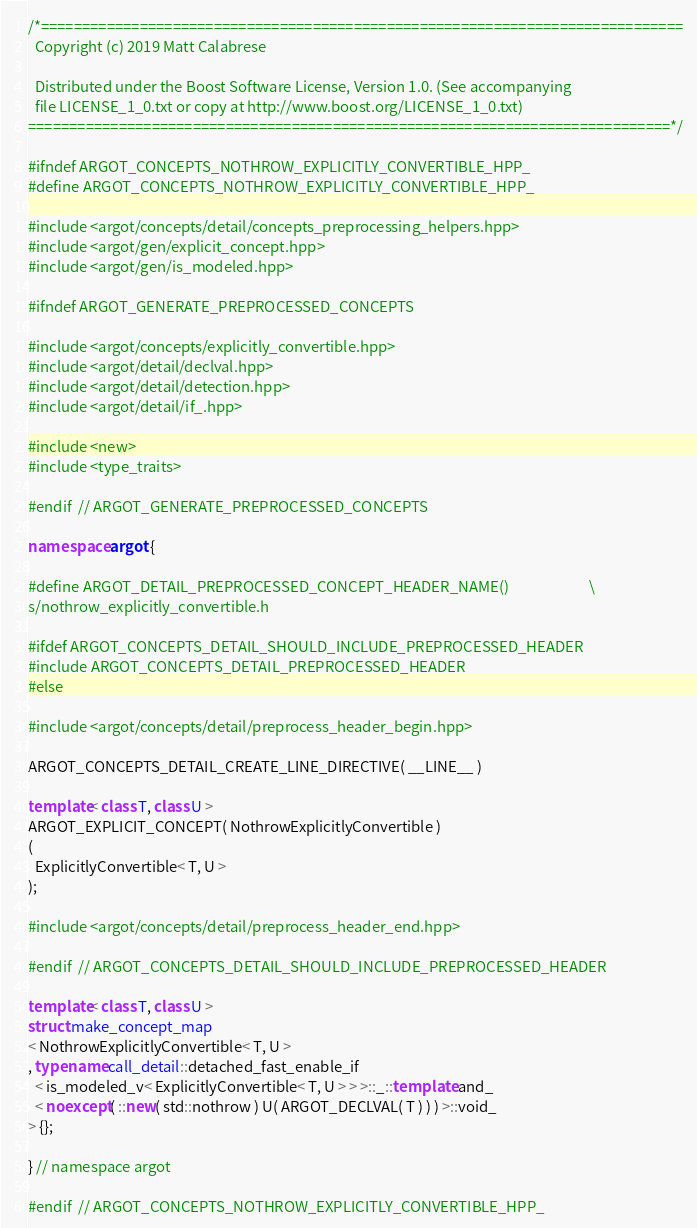<code> <loc_0><loc_0><loc_500><loc_500><_C++_>/*==============================================================================
  Copyright (c) 2019 Matt Calabrese

  Distributed under the Boost Software License, Version 1.0. (See accompanying
  file LICENSE_1_0.txt or copy at http://www.boost.org/LICENSE_1_0.txt)
==============================================================================*/

#ifndef ARGOT_CONCEPTS_NOTHROW_EXPLICITLY_CONVERTIBLE_HPP_
#define ARGOT_CONCEPTS_NOTHROW_EXPLICITLY_CONVERTIBLE_HPP_

#include <argot/concepts/detail/concepts_preprocessing_helpers.hpp>
#include <argot/gen/explicit_concept.hpp>
#include <argot/gen/is_modeled.hpp>

#ifndef ARGOT_GENERATE_PREPROCESSED_CONCEPTS

#include <argot/concepts/explicitly_convertible.hpp>
#include <argot/detail/declval.hpp>
#include <argot/detail/detection.hpp>
#include <argot/detail/if_.hpp>

#include <new>
#include <type_traits>

#endif  // ARGOT_GENERATE_PREPROCESSED_CONCEPTS

namespace argot {

#define ARGOT_DETAIL_PREPROCESSED_CONCEPT_HEADER_NAME()                        \
s/nothrow_explicitly_convertible.h

#ifdef ARGOT_CONCEPTS_DETAIL_SHOULD_INCLUDE_PREPROCESSED_HEADER
#include ARGOT_CONCEPTS_DETAIL_PREPROCESSED_HEADER
#else

#include <argot/concepts/detail/preprocess_header_begin.hpp>

ARGOT_CONCEPTS_DETAIL_CREATE_LINE_DIRECTIVE( __LINE__ )

template< class T, class U >
ARGOT_EXPLICIT_CONCEPT( NothrowExplicitlyConvertible )
(
  ExplicitlyConvertible< T, U >
);

#include <argot/concepts/detail/preprocess_header_end.hpp>

#endif  // ARGOT_CONCEPTS_DETAIL_SHOULD_INCLUDE_PREPROCESSED_HEADER

template< class T, class U >
struct make_concept_map
< NothrowExplicitlyConvertible< T, U >
, typename call_detail::detached_fast_enable_if
  < is_modeled_v< ExplicitlyConvertible< T, U > > >::_::template and_
  < noexcept( ::new( std::nothrow ) U( ARGOT_DECLVAL( T ) ) ) >::void_
> {};

} // namespace argot

#endif  // ARGOT_CONCEPTS_NOTHROW_EXPLICITLY_CONVERTIBLE_HPP_
</code> 